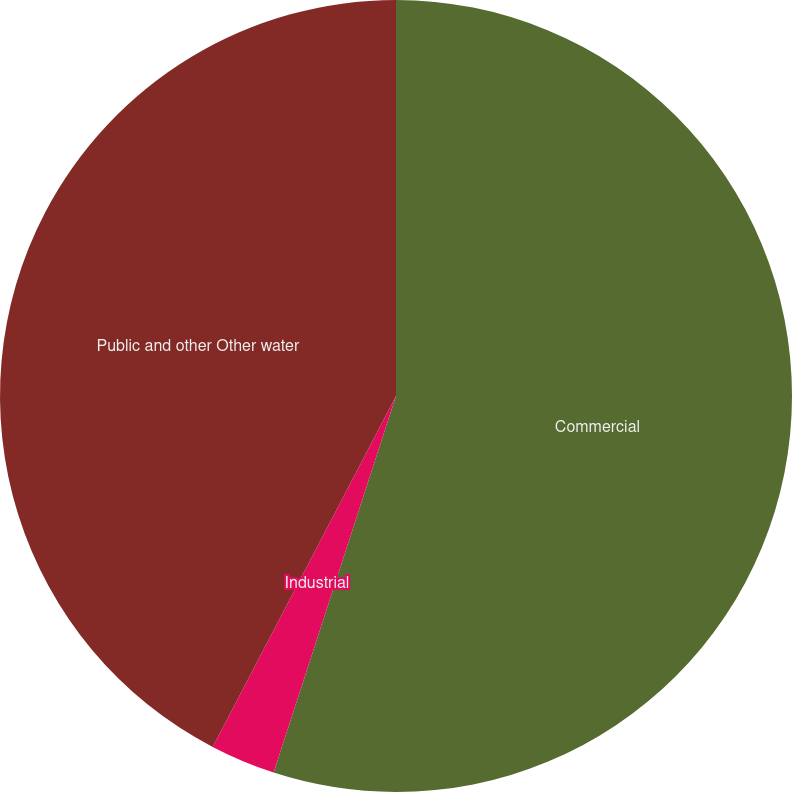Convert chart to OTSL. <chart><loc_0><loc_0><loc_500><loc_500><pie_chart><fcel>Commercial<fcel>Industrial<fcel>Public and other Other water<nl><fcel>55.0%<fcel>2.66%<fcel>42.34%<nl></chart> 